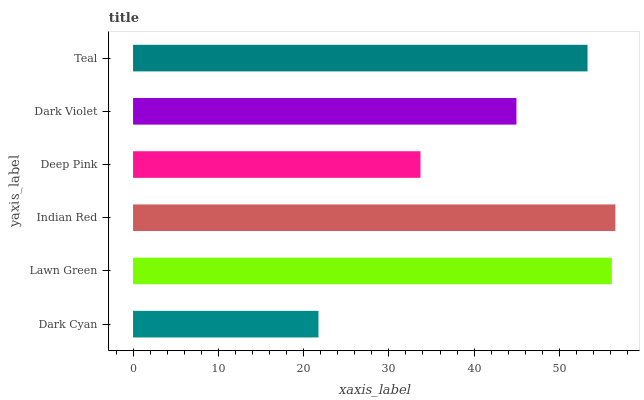Is Dark Cyan the minimum?
Answer yes or no. Yes. Is Indian Red the maximum?
Answer yes or no. Yes. Is Lawn Green the minimum?
Answer yes or no. No. Is Lawn Green the maximum?
Answer yes or no. No. Is Lawn Green greater than Dark Cyan?
Answer yes or no. Yes. Is Dark Cyan less than Lawn Green?
Answer yes or no. Yes. Is Dark Cyan greater than Lawn Green?
Answer yes or no. No. Is Lawn Green less than Dark Cyan?
Answer yes or no. No. Is Teal the high median?
Answer yes or no. Yes. Is Dark Violet the low median?
Answer yes or no. Yes. Is Deep Pink the high median?
Answer yes or no. No. Is Deep Pink the low median?
Answer yes or no. No. 